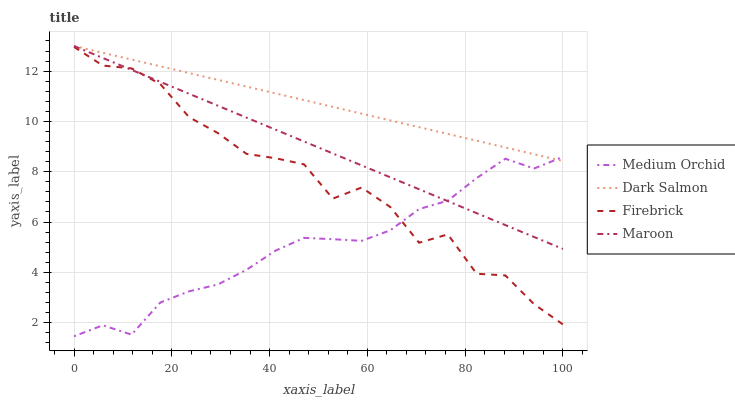Does Dark Salmon have the minimum area under the curve?
Answer yes or no. No. Does Medium Orchid have the maximum area under the curve?
Answer yes or no. No. Is Medium Orchid the smoothest?
Answer yes or no. No. Is Medium Orchid the roughest?
Answer yes or no. No. Does Dark Salmon have the lowest value?
Answer yes or no. No. Does Medium Orchid have the highest value?
Answer yes or no. No. Is Firebrick less than Dark Salmon?
Answer yes or no. Yes. Is Dark Salmon greater than Firebrick?
Answer yes or no. Yes. Does Firebrick intersect Dark Salmon?
Answer yes or no. No. 